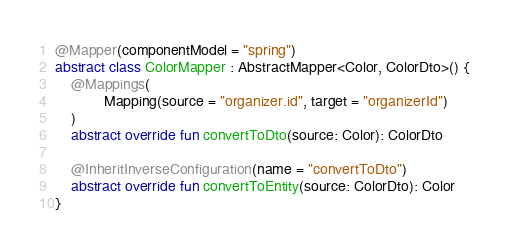Convert code to text. <code><loc_0><loc_0><loc_500><loc_500><_Kotlin_>@Mapper(componentModel = "spring")
abstract class ColorMapper : AbstractMapper<Color, ColorDto>() {
    @Mappings(
            Mapping(source = "organizer.id", target = "organizerId")
    )
    abstract override fun convertToDto(source: Color): ColorDto

    @InheritInverseConfiguration(name = "convertToDto")
    abstract override fun convertToEntity(source: ColorDto): Color
}
</code> 